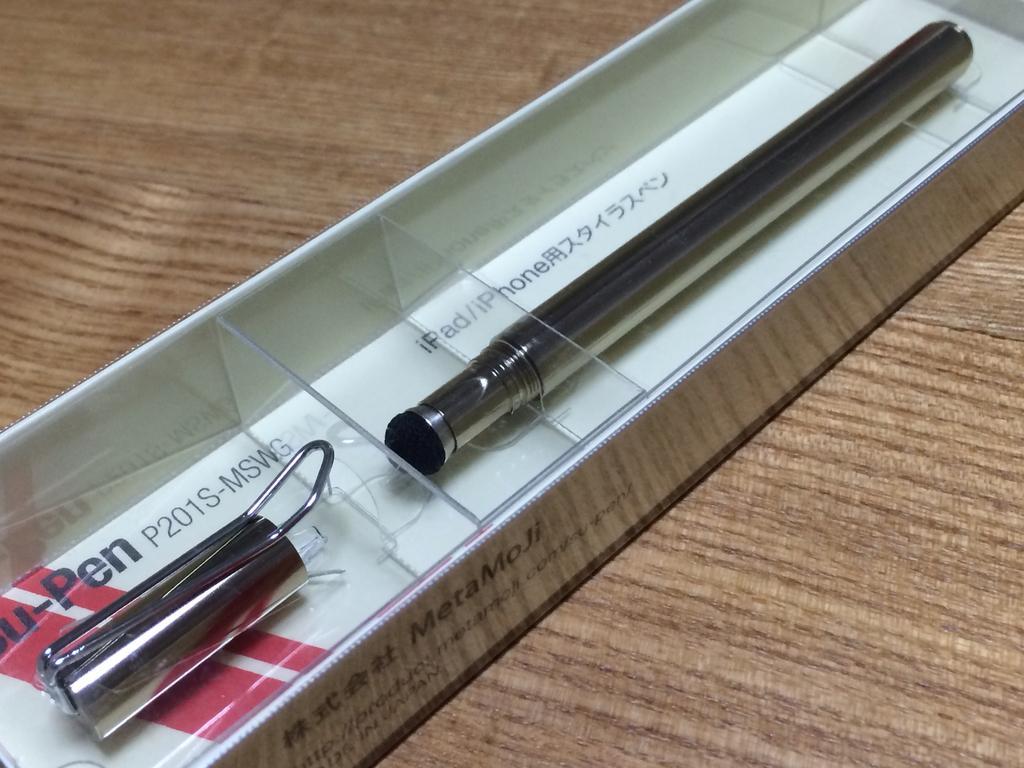Describe this image in one or two sentences. In the picture there is an object kept in a box and placed on a table. 